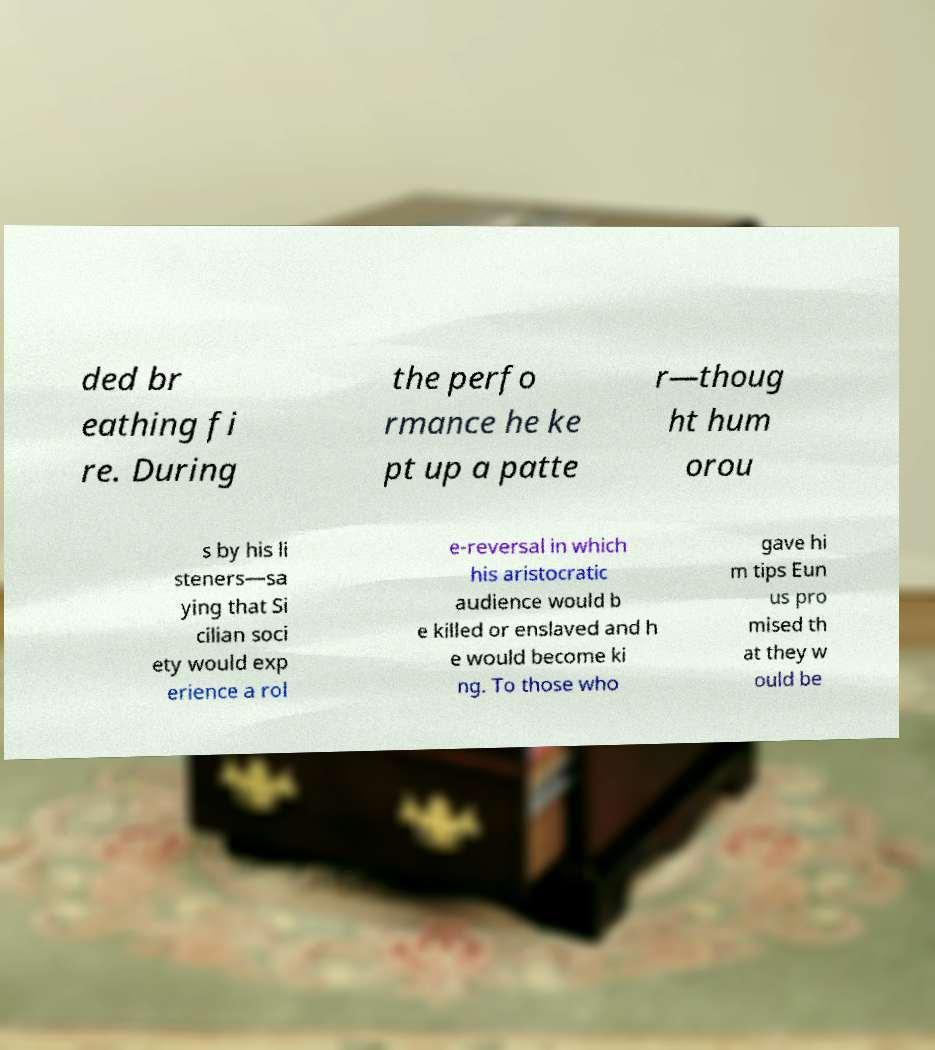Can you accurately transcribe the text from the provided image for me? ded br eathing fi re. During the perfo rmance he ke pt up a patte r—thoug ht hum orou s by his li steners—sa ying that Si cilian soci ety would exp erience a rol e-reversal in which his aristocratic audience would b e killed or enslaved and h e would become ki ng. To those who gave hi m tips Eun us pro mised th at they w ould be 